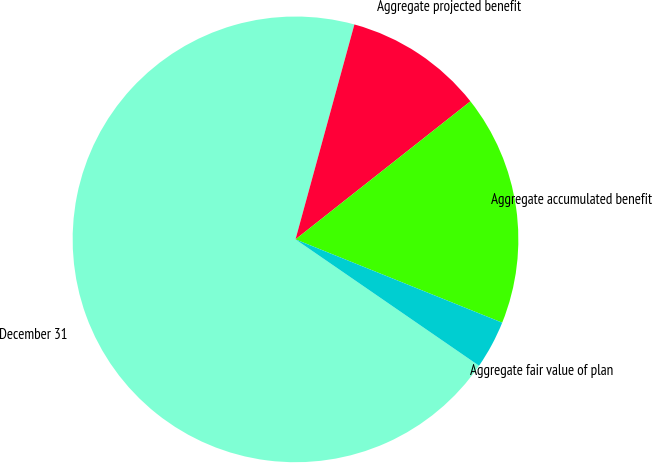Convert chart to OTSL. <chart><loc_0><loc_0><loc_500><loc_500><pie_chart><fcel>December 31<fcel>Aggregate projected benefit<fcel>Aggregate accumulated benefit<fcel>Aggregate fair value of plan<nl><fcel>69.66%<fcel>10.11%<fcel>16.73%<fcel>3.5%<nl></chart> 